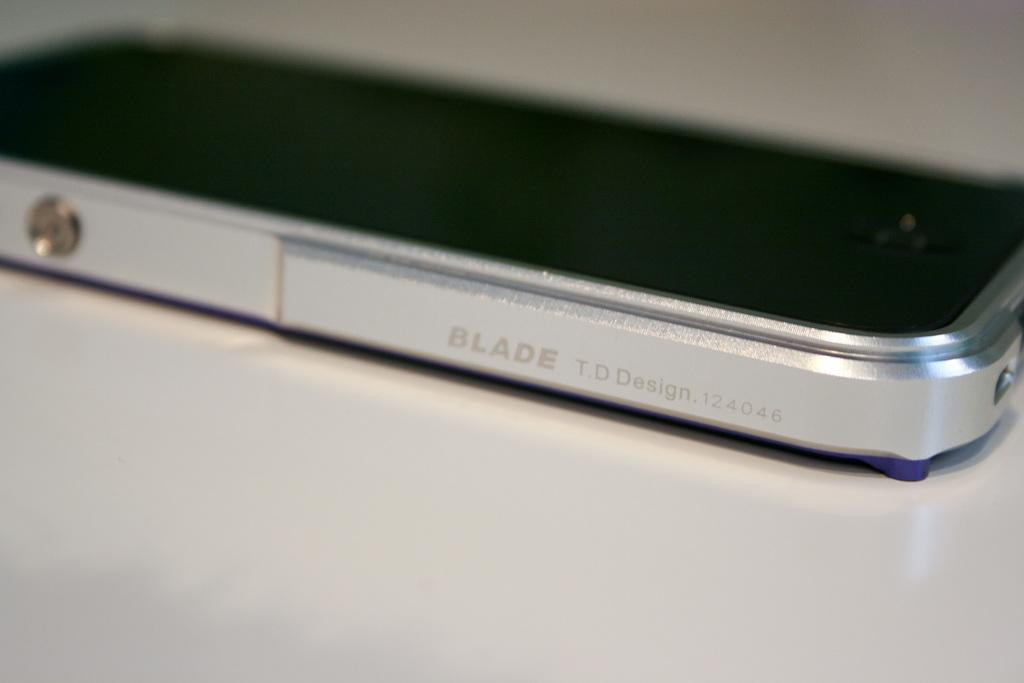<image>
Give a short and clear explanation of the subsequent image. Box shaped electronic with the work BLADE on the side 